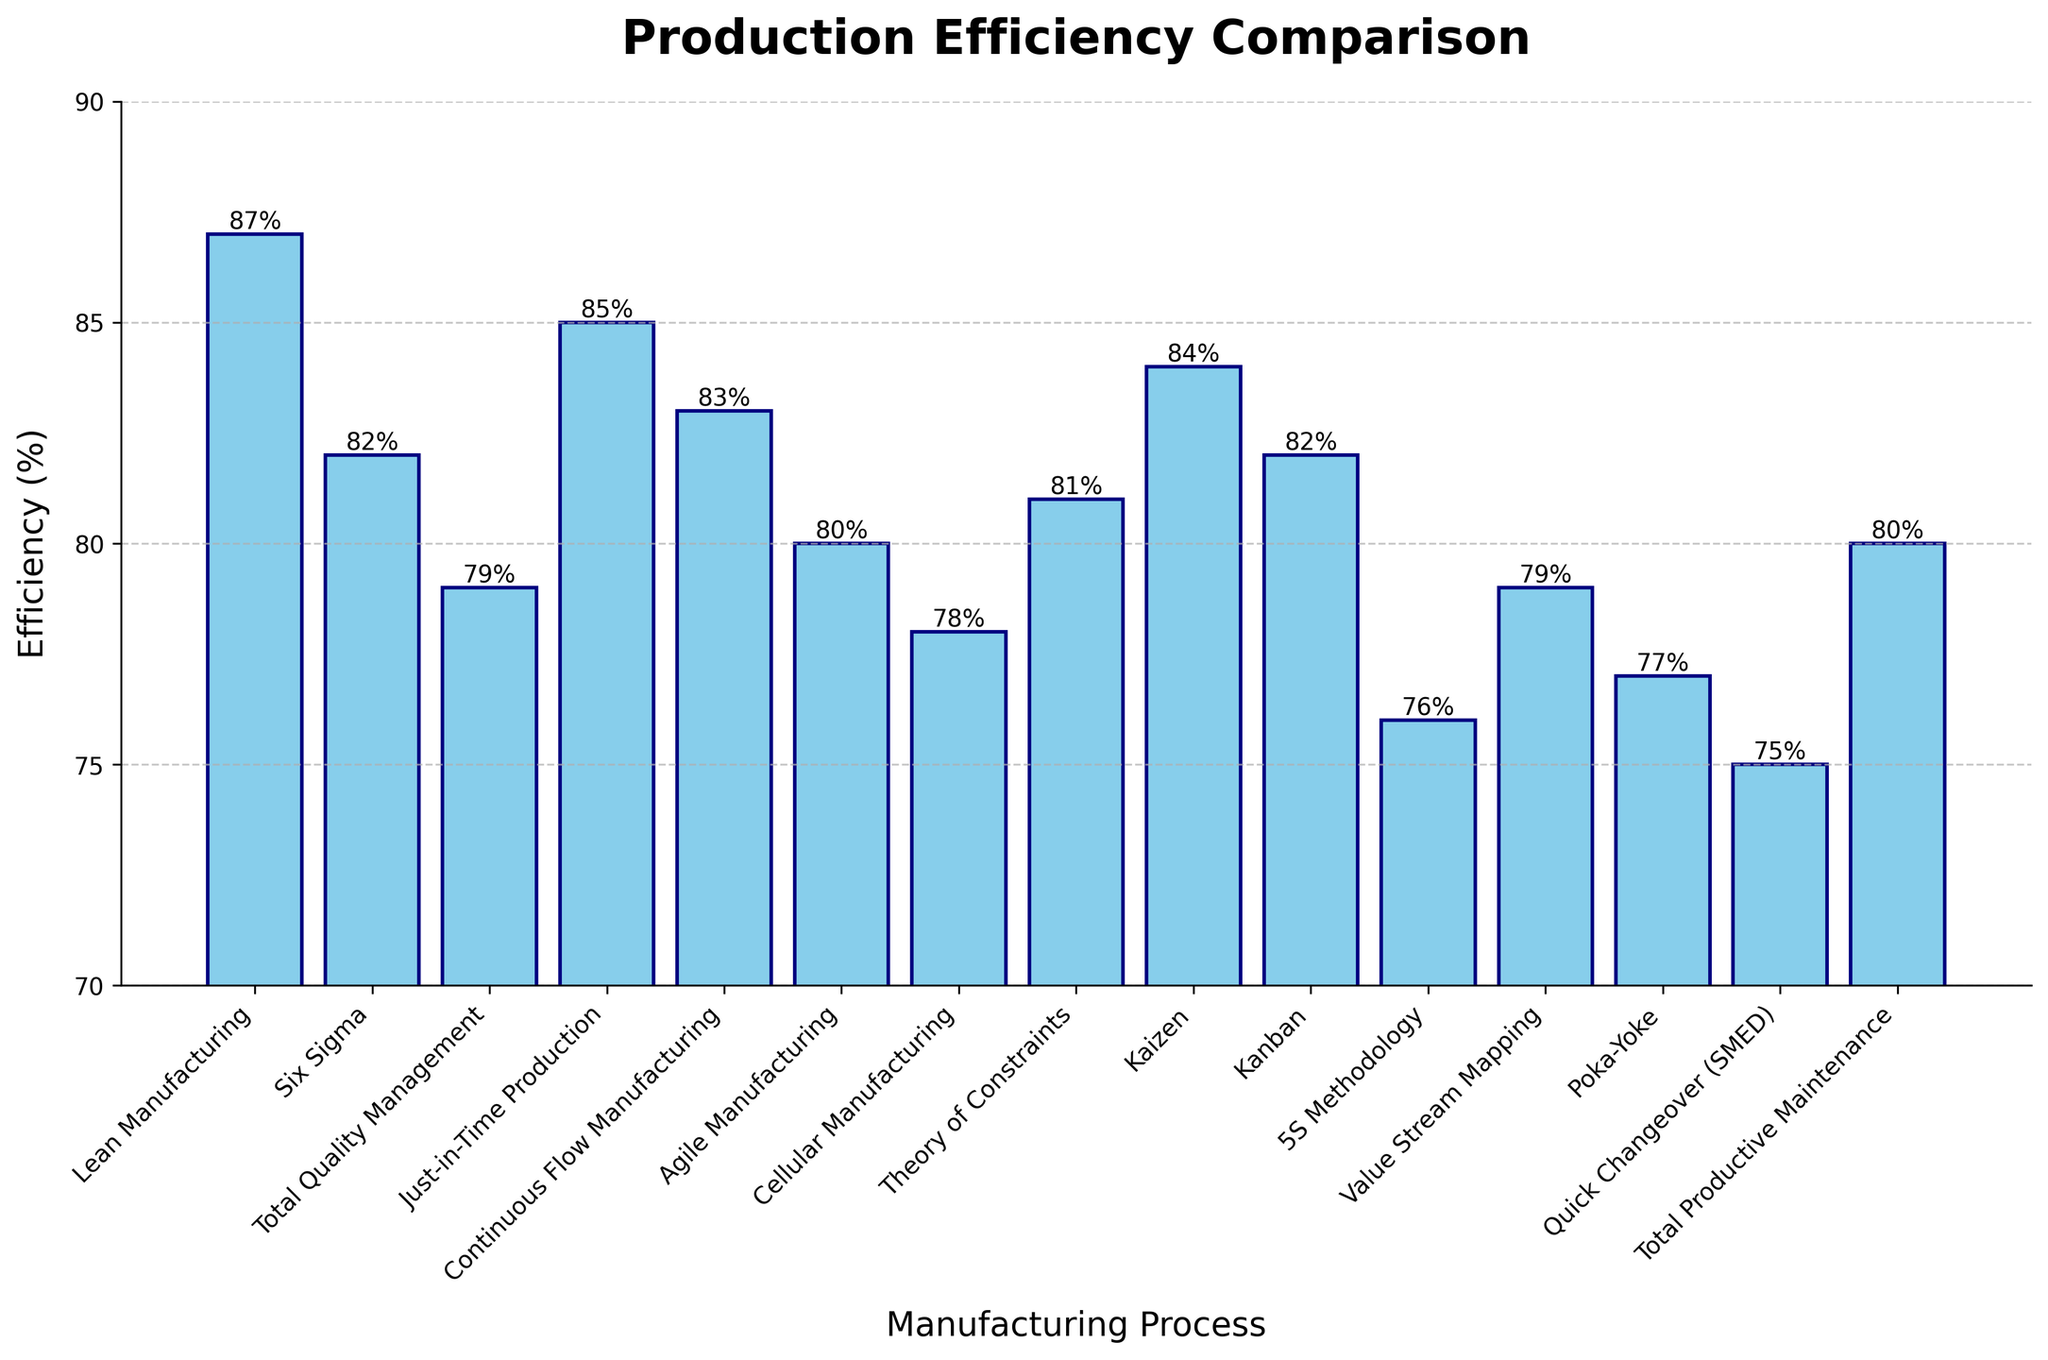What is the production process with the highest efficiency? The bar representing Lean Manufacturing has the tallest height, indicating it has the highest efficiency rate.
Answer: Lean Manufacturing Which two processes have an efficiency difference of 2%? Comparing the heights of the bars, Six Sigma and Kanban both have efficiencies of 82%, and Just-in-Time Production has 85%, and Theory of Constraints has 81%, showing that Just-in-Time Production is 2% higher than Theory of Constraints.
Answer: Just-in-Time Production and Theory of Constraints How does the efficiency of Quick Changeover (SMED) compare to the efficiency of Total Productive Maintenance? The bar for Quick Changeover (SMED) is at 75%, and the bar for Total Productive Maintenance is at 80%. Total Productive Maintenance is 5% more efficient.
Answer: Total Productive Maintenance is 5% higher What is the average efficiency of the top four most efficient processes? The top four processes by efficiency are Lean Manufacturing (87%), Just-in-Time Production (85%), Kaizen (84%), and Continuous Flow Manufacturing (83%). To find the average: (87 + 85 + 84 + 83) / 4 = 339 / 4 = 84.75%
Answer: 84.75% What is the efficiency difference between the highest and lowest efficiency processes? The highest efficiency is Lean Manufacturing at 87%, and the lowest is Quick Changeover (SMED) at 75%. The difference is 87% - 75% = 12%.
Answer: 12% Which processes have an efficiency above 80%? Lean Manufacturing (87%), Just-in-Time Production (85%), Kaizen (84%), Continuous Flow Manufacturing (83%), Six Sigma (82%), Kanban (82%), Theory of Constraints (81%), and Total Productive Maintenance (80%) all have efficiencies above 80%.
Answer: Lean Manufacturing, Just-in-Time Production, Kaizen, Continuous Flow Manufacturing, Six Sigma, Kanban, Theory of Constraints, Total Productive Maintenance What is the cumulative efficiency of Six Sigma, Agile Manufacturing, and Poka-Yoke? Adding the efficiencies: Six Sigma (82%), Agile Manufacturing (80%), and Poka-Yoke (77%): 82 + 80 + 77 = 239%.
Answer: 239% Which process exhibits the median efficiency value, and what is that value? Listing the efficiencies in numerical order: 75%, 76%, 77%, 78%, 79%, 79%, 80%, 80%, 81%, 82%, 82%, 83%, 84%, 85%, 87%. The median value is the middle one: 80%. Agile Manufacturing (80%) and Total Productive Maintenance (80%) share the median efficiency.
Answer: Agile Manufacturing and Total Productive Maintenance, 80% What is the range of efficiency values across all manufacturing processes? The highest efficiency is 87% (Lean Manufacturing), and the lowest is 75% (Quick Changeover [SMED]). Therefore, the range is 87% - 75% = 12%.
Answer: 12% 